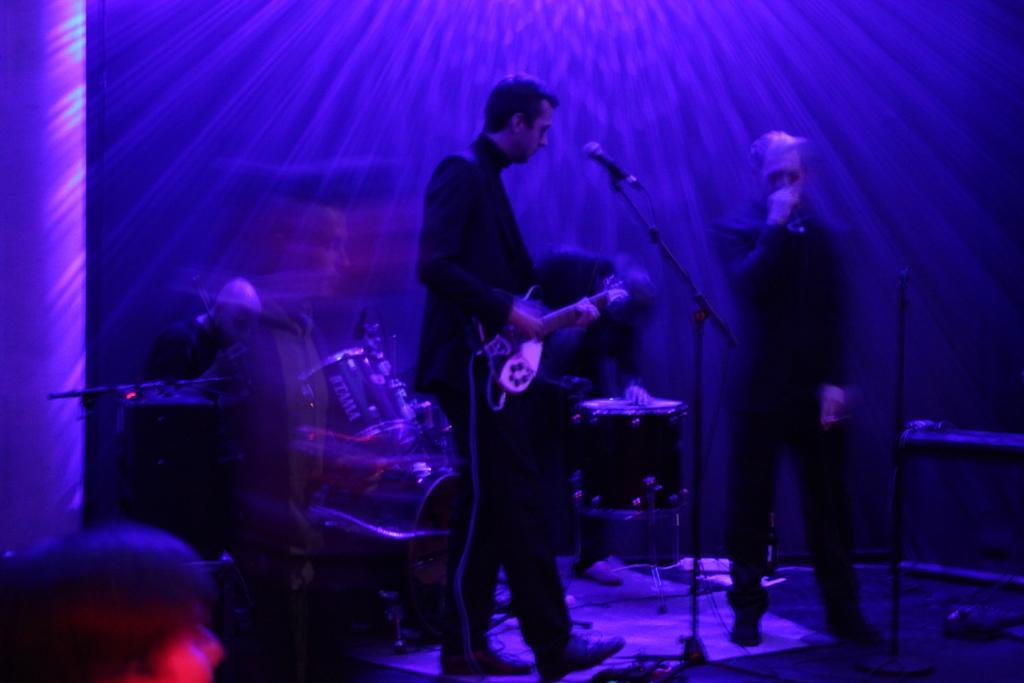In one or two sentences, can you explain what this image depicts? In this image I can see two men are standing among them this man is holding a guitar in hands. I can also see microphones and some other musical instruments on the stage. In the background I can see blue color lights. 